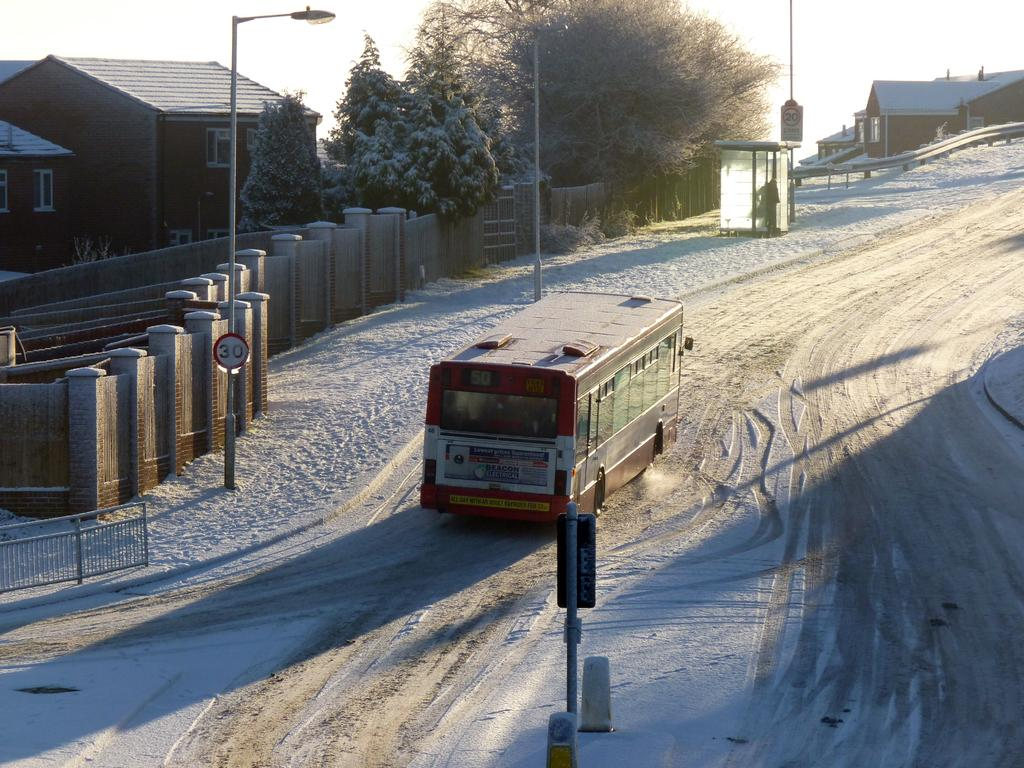What is the main object on the ground in the image? There is a vehicle on the ground in the image. What type of structures can be seen in the image? There are houses, poles, and a wall in the image. What type of natural elements are present in the image? There are trees in the image. What type of man-made objects are present in the image? There are lights, boards, and a railing in the image. What can be seen in the background of the image? The sky is visible in the background of the image. What type of quartz is used to construct the railing in the image? There is no quartz present in the image; the railing is made of a different material. How does the grip of the vehicle's tires affect its performance in the image? There is no information about the grip of the vehicle's tires in the image, so it cannot be determined how it affects its performance. 